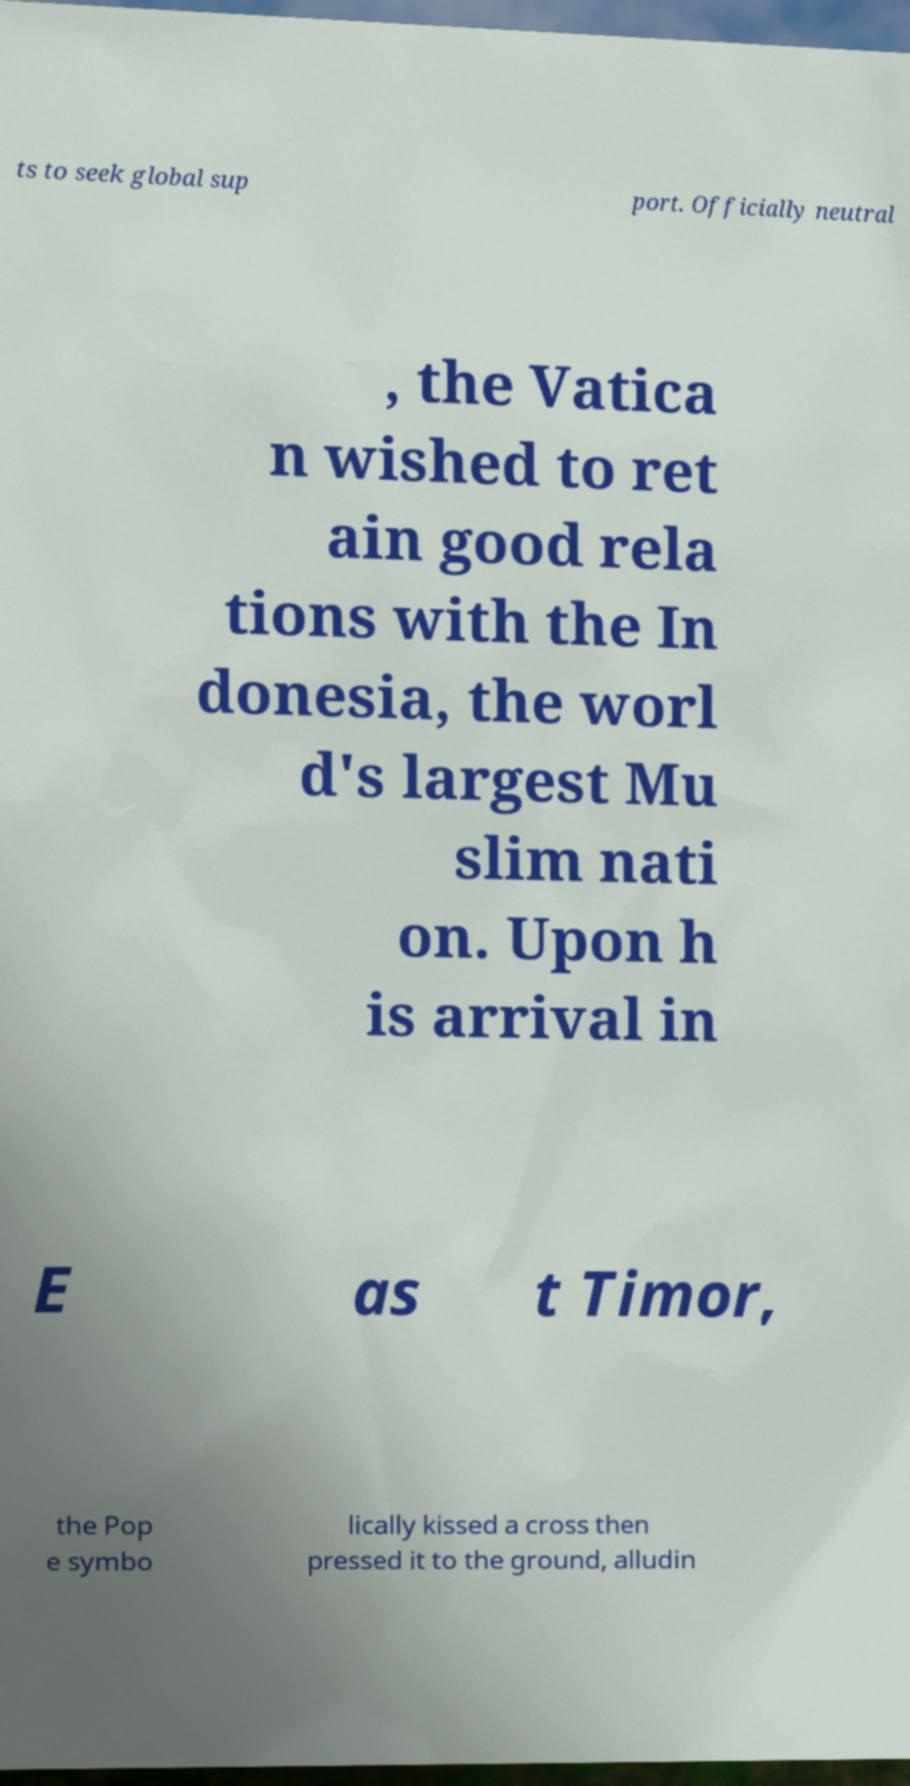Could you assist in decoding the text presented in this image and type it out clearly? ts to seek global sup port. Officially neutral , the Vatica n wished to ret ain good rela tions with the In donesia, the worl d's largest Mu slim nati on. Upon h is arrival in E as t Timor, the Pop e symbo lically kissed a cross then pressed it to the ground, alludin 